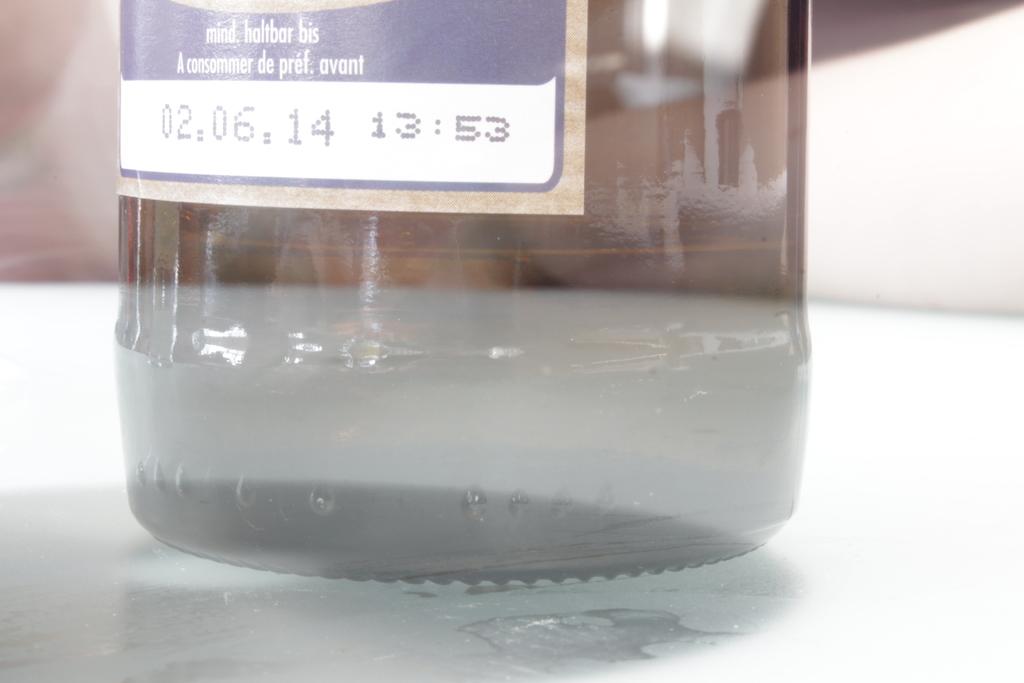What date is written on the bottle?
Your answer should be very brief. 02.06.14. What is the time stamped next to the date?
Your response must be concise. 13:53. 